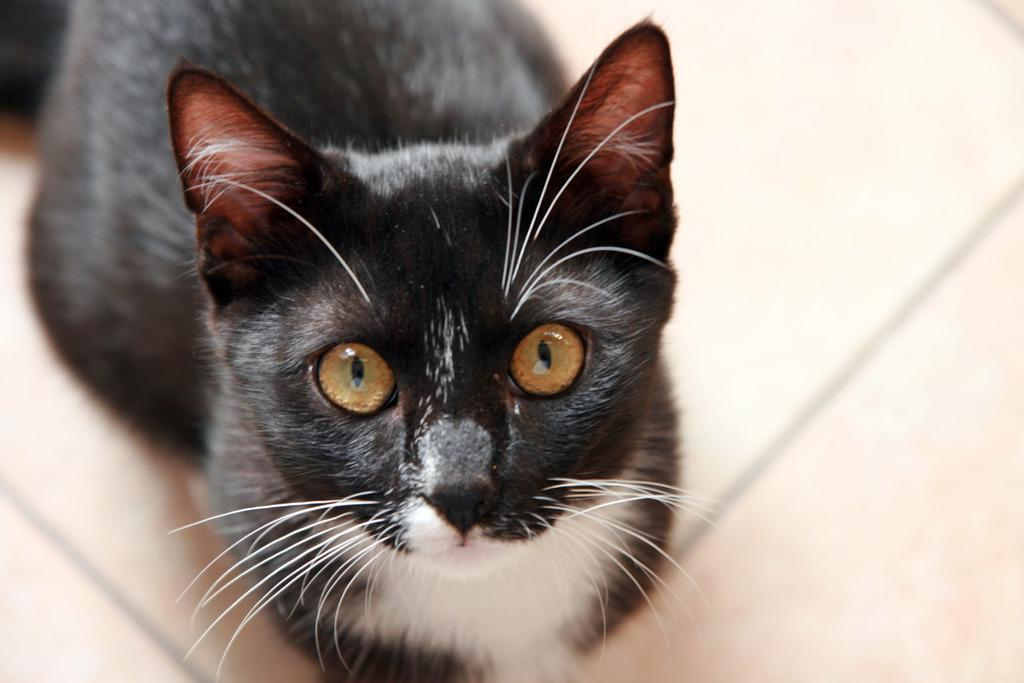What type of animal is in the image? There is a black color cat in the image. What direction is the cat looking in? The cat is looking at this side. Is the cat sitting on a throne in the image? There is no throne present in the image; it only features a black color cat. What type of toys can be seen with the cat in the image? There are no toys visible in the image, as it only features a black color cat. 